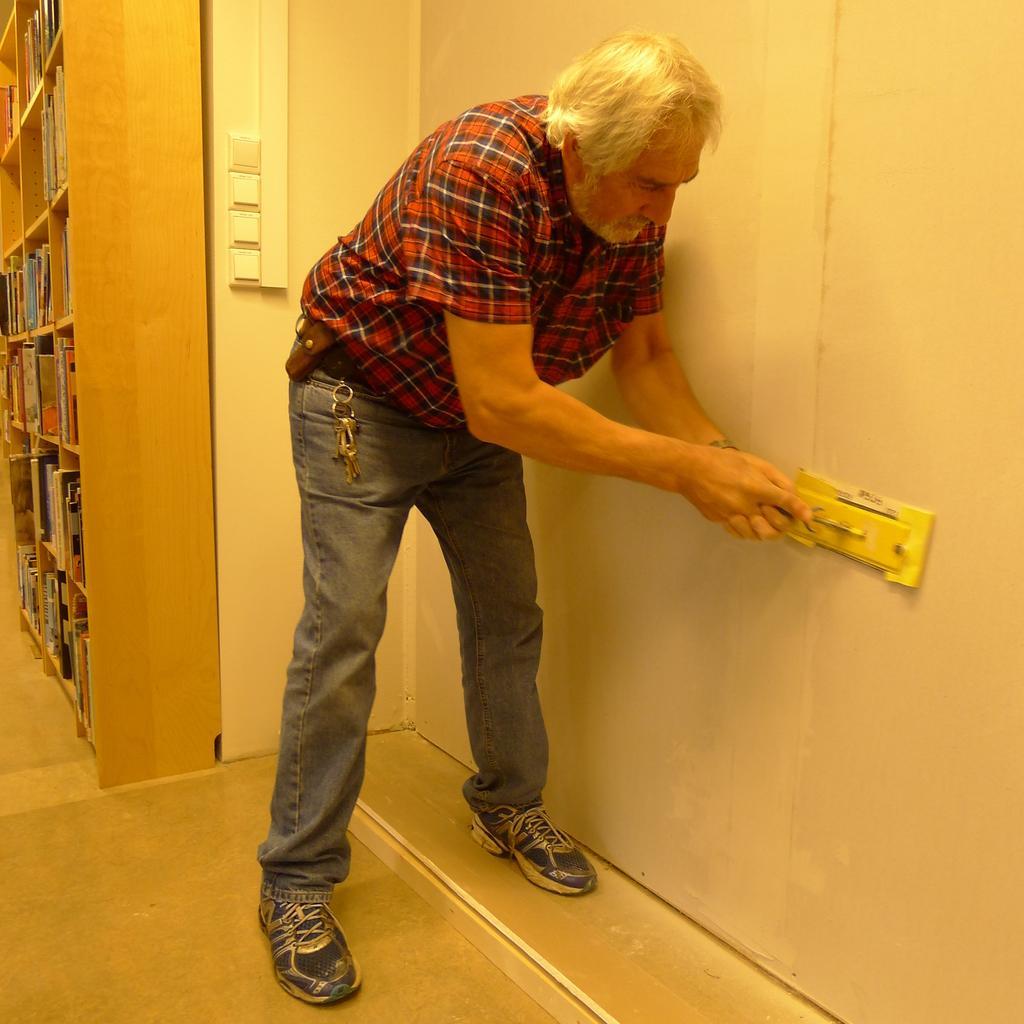In one or two sentences, can you explain what this image depicts? In this image we can see a person holding an object. There are few objects on the wall. There are many books on the rack. We can see the keys in the image. 